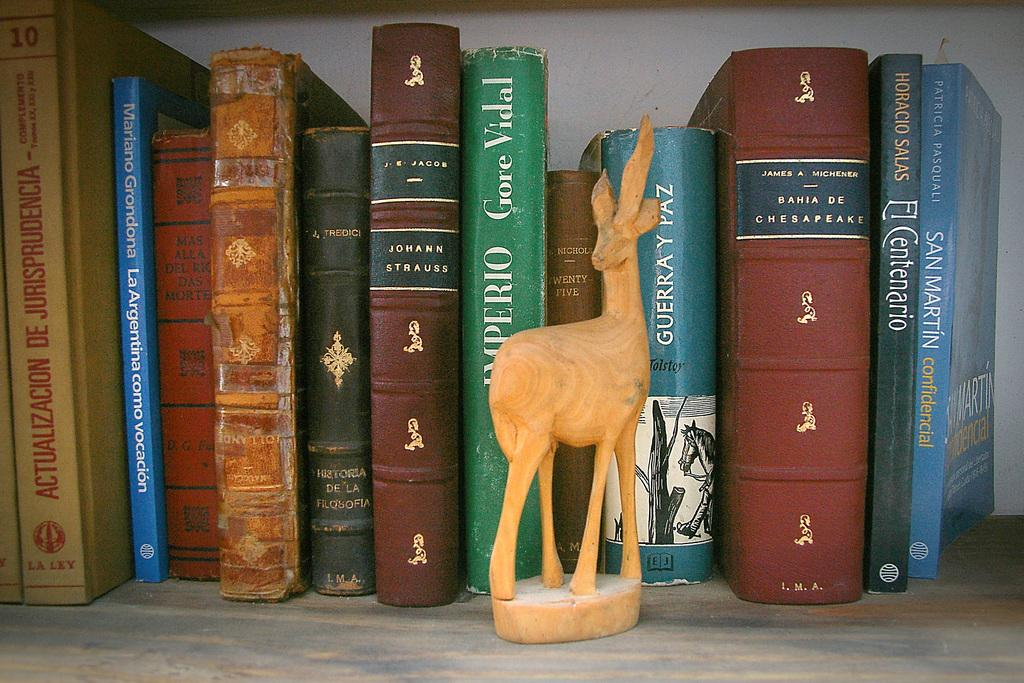<image>
Summarize the visual content of the image. A book called El Centenario is lined up with some other books on a shelf. 